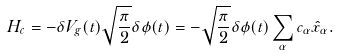<formula> <loc_0><loc_0><loc_500><loc_500>H _ { c } = - \delta V _ { g } ( t ) \sqrt { \frac { \pi } { 2 } } \delta \phi ( t ) = - \sqrt { \frac { \pi } { 2 } } \delta \phi ( t ) \sum _ { \alpha } c _ { \alpha } \hat { x } _ { \alpha } .</formula> 